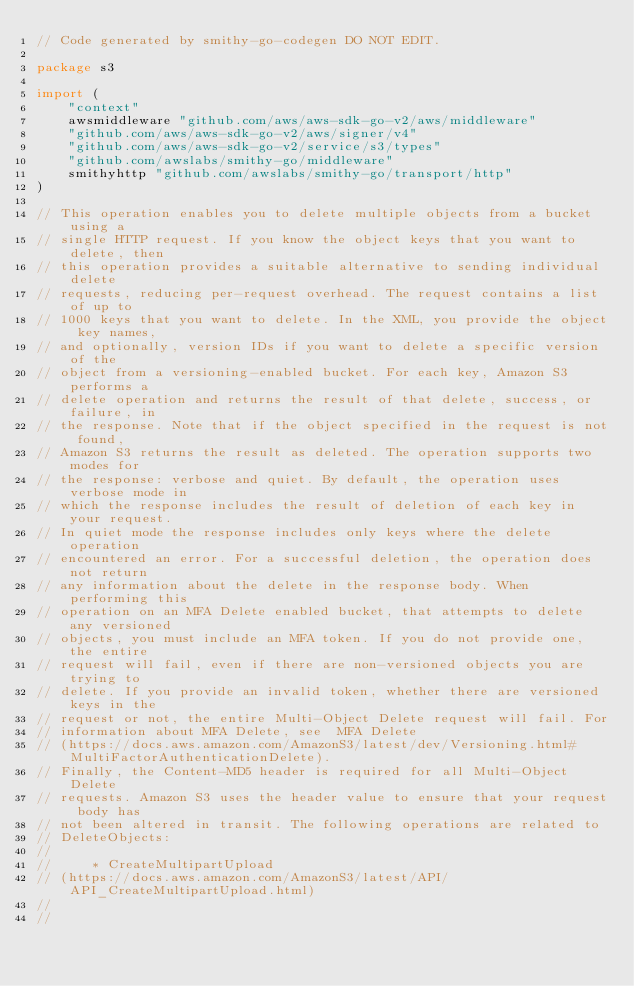<code> <loc_0><loc_0><loc_500><loc_500><_Go_>// Code generated by smithy-go-codegen DO NOT EDIT.

package s3

import (
	"context"
	awsmiddleware "github.com/aws/aws-sdk-go-v2/aws/middleware"
	"github.com/aws/aws-sdk-go-v2/aws/signer/v4"
	"github.com/aws/aws-sdk-go-v2/service/s3/types"
	"github.com/awslabs/smithy-go/middleware"
	smithyhttp "github.com/awslabs/smithy-go/transport/http"
)

// This operation enables you to delete multiple objects from a bucket using a
// single HTTP request. If you know the object keys that you want to delete, then
// this operation provides a suitable alternative to sending individual delete
// requests, reducing per-request overhead. The request contains a list of up to
// 1000 keys that you want to delete. In the XML, you provide the object key names,
// and optionally, version IDs if you want to delete a specific version of the
// object from a versioning-enabled bucket. For each key, Amazon S3 performs a
// delete operation and returns the result of that delete, success, or failure, in
// the response. Note that if the object specified in the request is not found,
// Amazon S3 returns the result as deleted. The operation supports two modes for
// the response: verbose and quiet. By default, the operation uses verbose mode in
// which the response includes the result of deletion of each key in your request.
// In quiet mode the response includes only keys where the delete operation
// encountered an error. For a successful deletion, the operation does not return
// any information about the delete in the response body. When performing this
// operation on an MFA Delete enabled bucket, that attempts to delete any versioned
// objects, you must include an MFA token. If you do not provide one, the entire
// request will fail, even if there are non-versioned objects you are trying to
// delete. If you provide an invalid token, whether there are versioned keys in the
// request or not, the entire Multi-Object Delete request will fail. For
// information about MFA Delete, see  MFA Delete
// (https://docs.aws.amazon.com/AmazonS3/latest/dev/Versioning.html#MultiFactorAuthenticationDelete).
// Finally, the Content-MD5 header is required for all Multi-Object Delete
// requests. Amazon S3 uses the header value to ensure that your request body has
// not been altered in transit. The following operations are related to
// DeleteObjects:
//
//     * CreateMultipartUpload
// (https://docs.aws.amazon.com/AmazonS3/latest/API/API_CreateMultipartUpload.html)
//
//</code> 